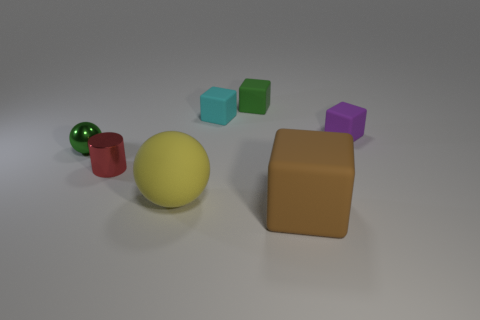Subtract all big brown cubes. How many cubes are left? 3 Subtract all green cubes. How many cubes are left? 3 Add 1 small green metal cylinders. How many objects exist? 8 Subtract all blocks. How many objects are left? 3 Add 4 metal things. How many metal things exist? 6 Subtract 1 green cubes. How many objects are left? 6 Subtract 3 cubes. How many cubes are left? 1 Subtract all cyan spheres. Subtract all gray cubes. How many spheres are left? 2 Subtract all cyan spheres. How many purple cubes are left? 1 Subtract all red cylinders. Subtract all green matte cubes. How many objects are left? 5 